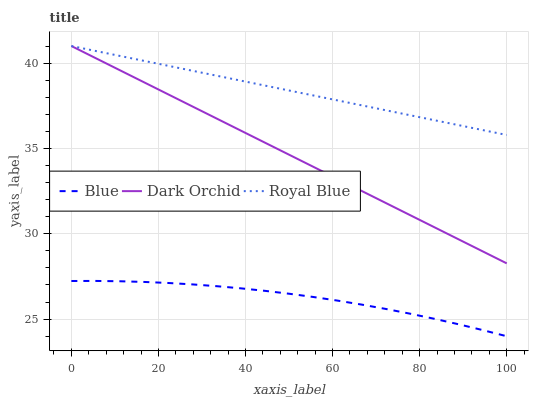Does Blue have the minimum area under the curve?
Answer yes or no. Yes. Does Royal Blue have the maximum area under the curve?
Answer yes or no. Yes. Does Dark Orchid have the minimum area under the curve?
Answer yes or no. No. Does Dark Orchid have the maximum area under the curve?
Answer yes or no. No. Is Dark Orchid the smoothest?
Answer yes or no. Yes. Is Blue the roughest?
Answer yes or no. Yes. Is Royal Blue the smoothest?
Answer yes or no. No. Is Royal Blue the roughest?
Answer yes or no. No. Does Blue have the lowest value?
Answer yes or no. Yes. Does Dark Orchid have the lowest value?
Answer yes or no. No. Does Dark Orchid have the highest value?
Answer yes or no. Yes. Is Blue less than Royal Blue?
Answer yes or no. Yes. Is Royal Blue greater than Blue?
Answer yes or no. Yes. Does Royal Blue intersect Dark Orchid?
Answer yes or no. Yes. Is Royal Blue less than Dark Orchid?
Answer yes or no. No. Is Royal Blue greater than Dark Orchid?
Answer yes or no. No. Does Blue intersect Royal Blue?
Answer yes or no. No. 